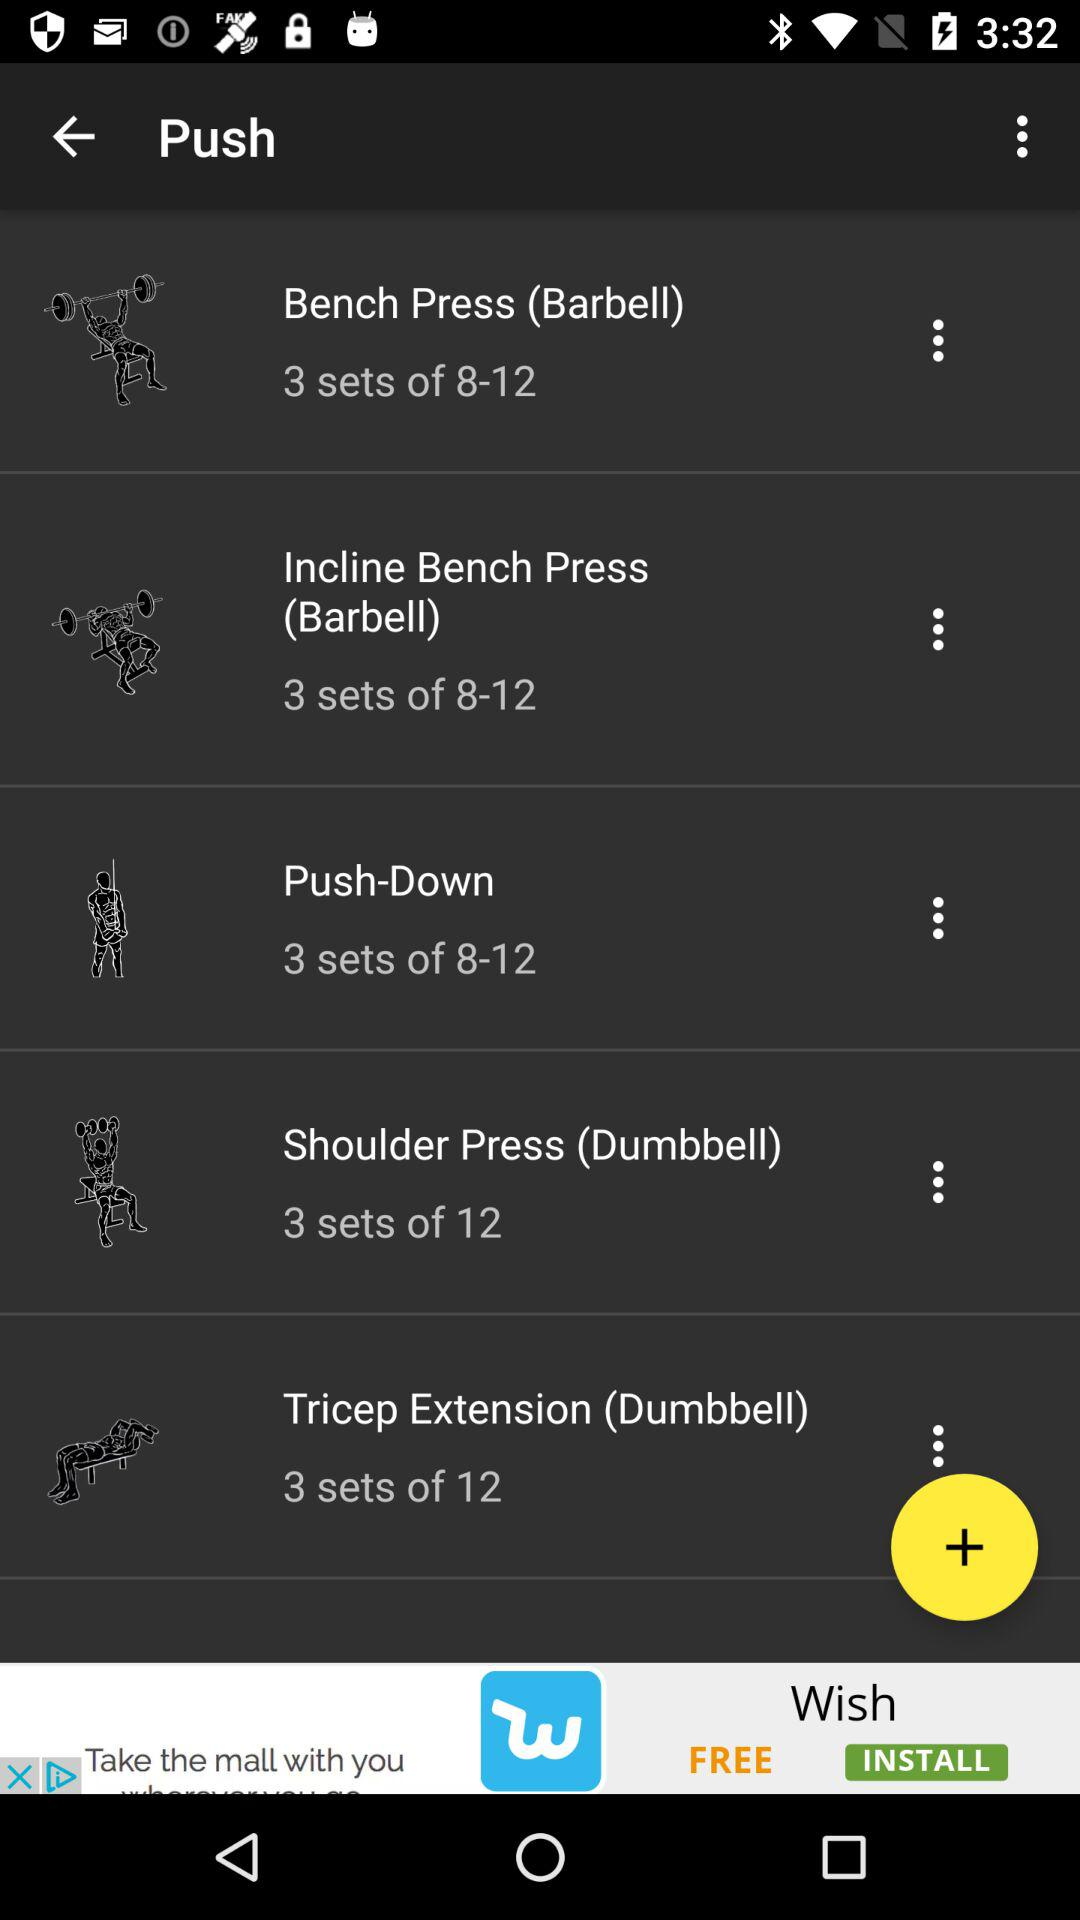How many sets are there for Tricep Extension (Dumbbell)?
Answer the question using a single word or phrase. 3 